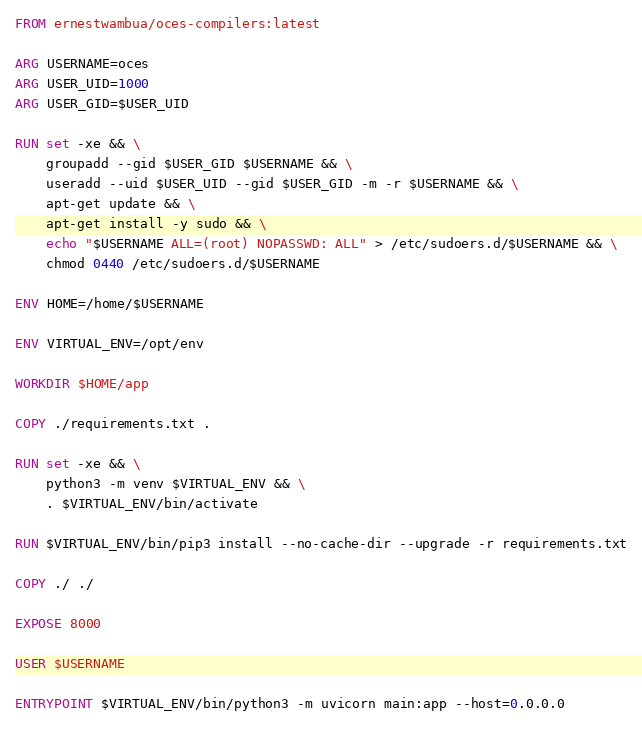Convert code to text. <code><loc_0><loc_0><loc_500><loc_500><_Dockerfile_>FROM ernestwambua/oces-compilers:latest

ARG USERNAME=oces
ARG USER_UID=1000
ARG USER_GID=$USER_UID

RUN set -xe && \
    groupadd --gid $USER_GID $USERNAME && \
    useradd --uid $USER_UID --gid $USER_GID -m -r $USERNAME && \
    apt-get update && \
    apt-get install -y sudo && \
    echo "$USERNAME ALL=(root) NOPASSWD: ALL" > /etc/sudoers.d/$USERNAME && \
    chmod 0440 /etc/sudoers.d/$USERNAME

ENV HOME=/home/$USERNAME

ENV VIRTUAL_ENV=/opt/env

WORKDIR $HOME/app

COPY ./requirements.txt .

RUN set -xe && \
    python3 -m venv $VIRTUAL_ENV && \
    . $VIRTUAL_ENV/bin/activate

RUN $VIRTUAL_ENV/bin/pip3 install --no-cache-dir --upgrade -r requirements.txt

COPY ./ ./

EXPOSE 8000

USER $USERNAME

ENTRYPOINT $VIRTUAL_ENV/bin/python3 -m uvicorn main:app --host=0.0.0.0</code> 